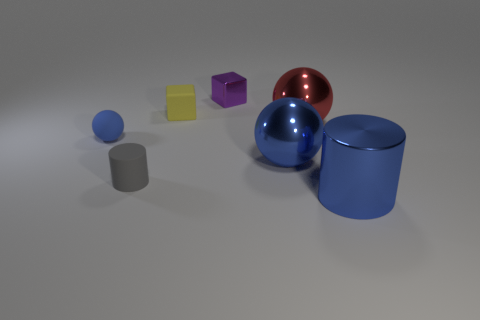Is there any significance to the arrangement of shapes? The arrangement of shapes might not have a specific significance, but it reflects a balanced composition used to compare and contrast the forms and colors, which can be of interest in visual arts or design studies. 